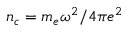<formula> <loc_0><loc_0><loc_500><loc_500>n _ { c } = m _ { e } \omega ^ { 2 } / 4 \pi e ^ { 2 }</formula> 